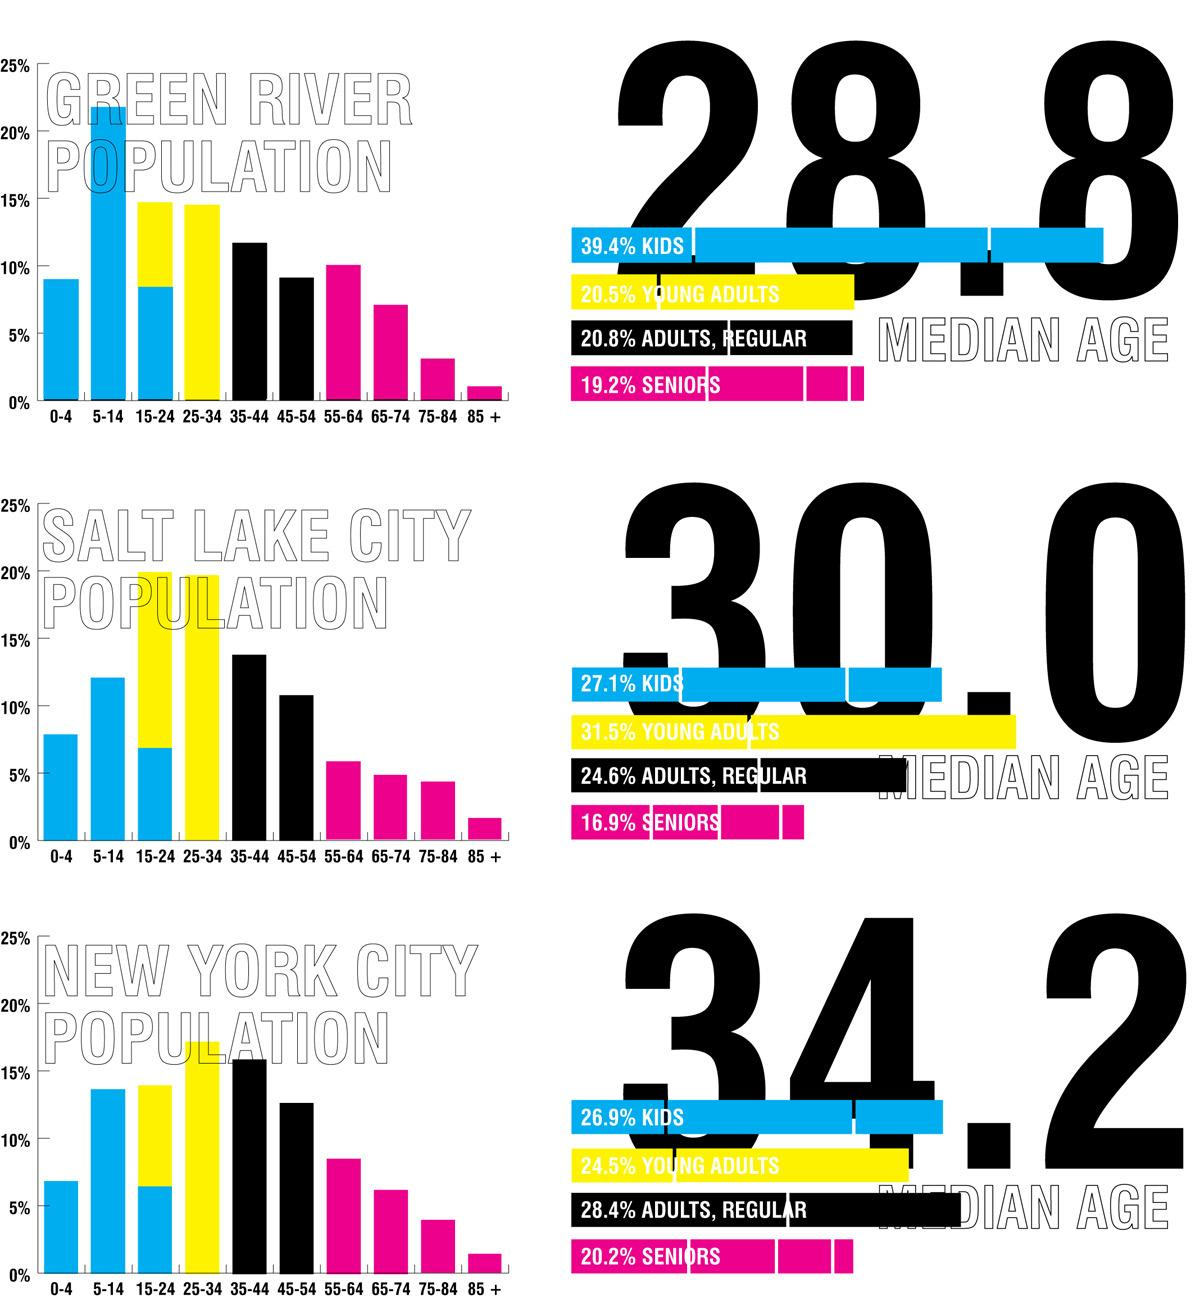Mention a couple of crucial points in this snapshot. The percentage of children and seniors in New York City is 47.1%. The population of Green River consists of 58.6% children and seniors, according to the most recent data available. According to data for Salt Lake City, 44% of the population consists of both children and seniors. According to recent statistics, approximately 51.4% of the population in New York City consists of children and young adults combined. According to a recent survey, in Salt Lake City, 58.6% of the population is comprised of children and young adults. 